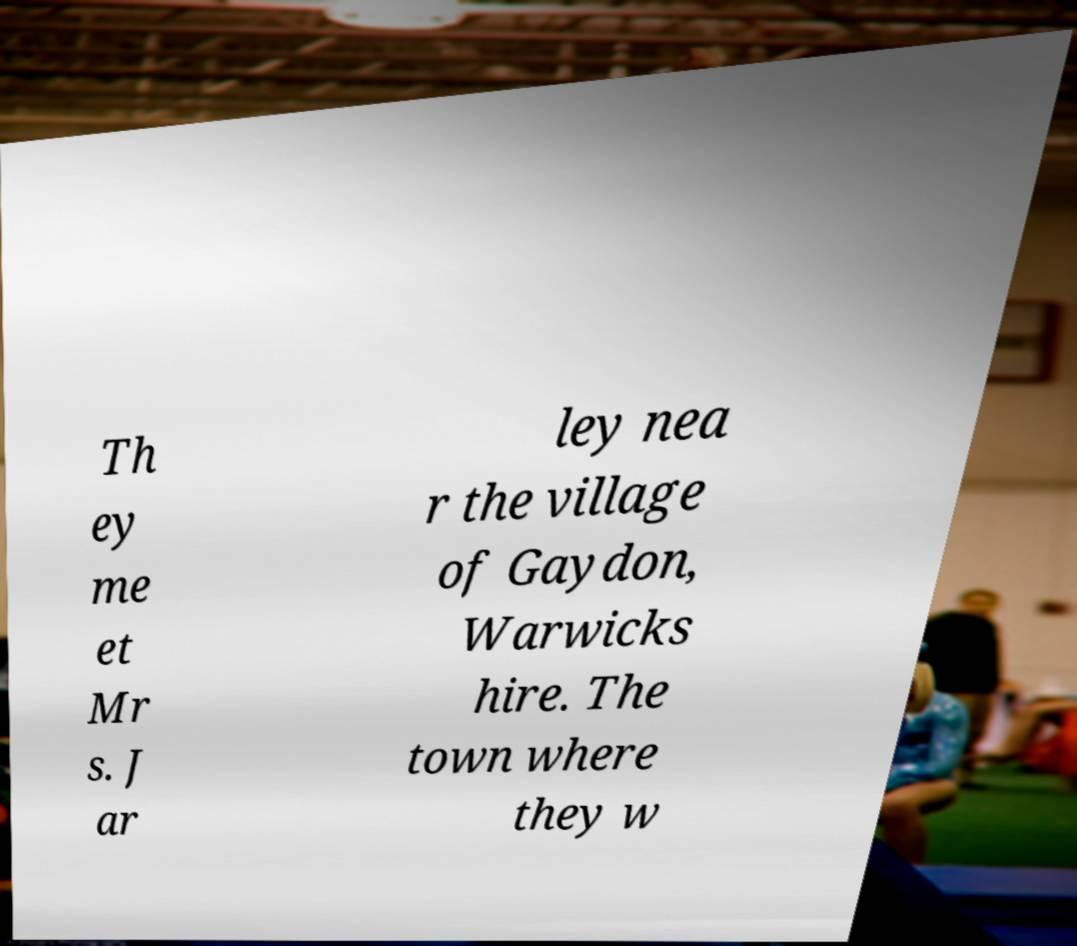Could you extract and type out the text from this image? Th ey me et Mr s. J ar ley nea r the village of Gaydon, Warwicks hire. The town where they w 